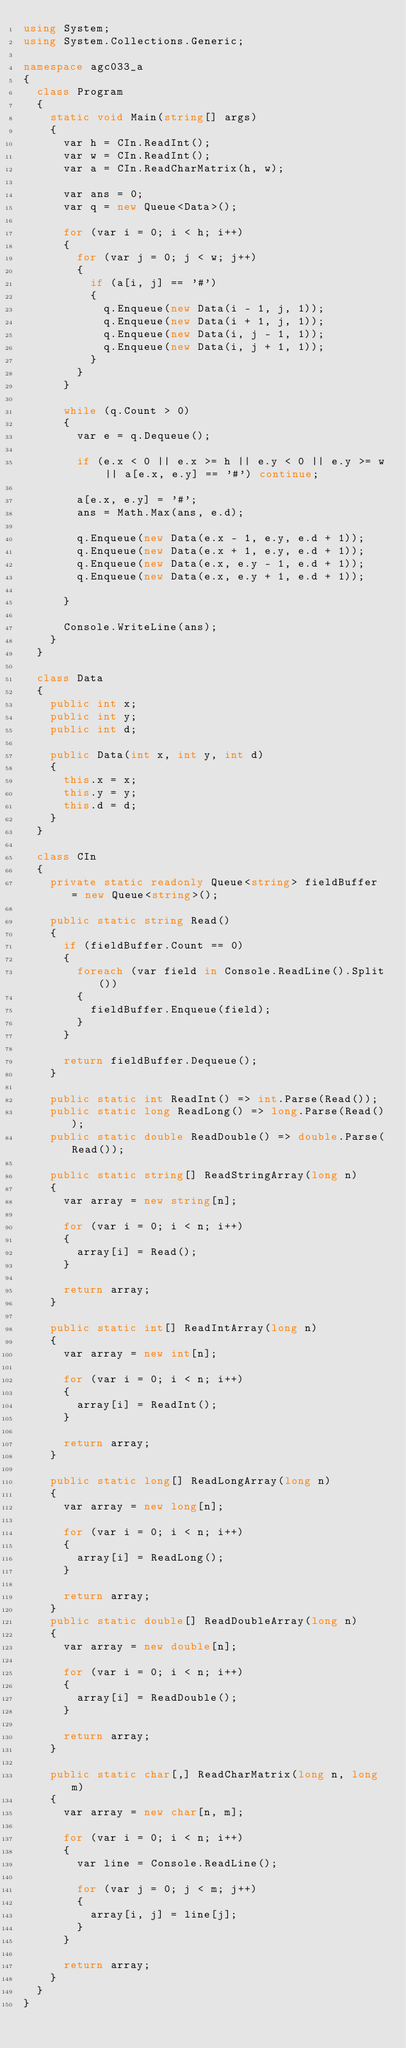<code> <loc_0><loc_0><loc_500><loc_500><_C#_>using System;
using System.Collections.Generic;

namespace agc033_a
{
  class Program
  {
    static void Main(string[] args)
    {
      var h = CIn.ReadInt();
      var w = CIn.ReadInt();
      var a = CIn.ReadCharMatrix(h, w);

      var ans = 0;
      var q = new Queue<Data>();

      for (var i = 0; i < h; i++)
      {
        for (var j = 0; j < w; j++)
        {
          if (a[i, j] == '#')
          {
            q.Enqueue(new Data(i - 1, j, 1));
            q.Enqueue(new Data(i + 1, j, 1));
            q.Enqueue(new Data(i, j - 1, 1));
            q.Enqueue(new Data(i, j + 1, 1));
          }
        }
      }

      while (q.Count > 0)
      {
        var e = q.Dequeue();

        if (e.x < 0 || e.x >= h || e.y < 0 || e.y >= w || a[e.x, e.y] == '#') continue;

        a[e.x, e.y] = '#';
        ans = Math.Max(ans, e.d);

        q.Enqueue(new Data(e.x - 1, e.y, e.d + 1));
        q.Enqueue(new Data(e.x + 1, e.y, e.d + 1));
        q.Enqueue(new Data(e.x, e.y - 1, e.d + 1));
        q.Enqueue(new Data(e.x, e.y + 1, e.d + 1));

      }

      Console.WriteLine(ans);
    }
  }

  class Data
  {
    public int x;
    public int y;
    public int d;

    public Data(int x, int y, int d)
    {
      this.x = x;
      this.y = y;
      this.d = d;
    }
  }

  class CIn
  {
    private static readonly Queue<string> fieldBuffer = new Queue<string>();

    public static string Read()
    {
      if (fieldBuffer.Count == 0)
      {
        foreach (var field in Console.ReadLine().Split())
        {
          fieldBuffer.Enqueue(field);
        }
      }

      return fieldBuffer.Dequeue();
    }

    public static int ReadInt() => int.Parse(Read());
    public static long ReadLong() => long.Parse(Read());
    public static double ReadDouble() => double.Parse(Read());

    public static string[] ReadStringArray(long n)
    {
      var array = new string[n];

      for (var i = 0; i < n; i++)
      {
        array[i] = Read();
      }

      return array;
    }

    public static int[] ReadIntArray(long n)
    {
      var array = new int[n];

      for (var i = 0; i < n; i++)
      {
        array[i] = ReadInt();
      }

      return array;
    }

    public static long[] ReadLongArray(long n)
    {
      var array = new long[n];

      for (var i = 0; i < n; i++)
      {
        array[i] = ReadLong();
      }

      return array;
    }
    public static double[] ReadDoubleArray(long n)
    {
      var array = new double[n];

      for (var i = 0; i < n; i++)
      {
        array[i] = ReadDouble();
      }

      return array;
    }

    public static char[,] ReadCharMatrix(long n, long m)
    {
      var array = new char[n, m];

      for (var i = 0; i < n; i++)
      {
        var line = Console.ReadLine();

        for (var j = 0; j < m; j++)
        {
          array[i, j] = line[j];
        }
      }

      return array;
    }
  }
}</code> 